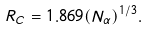<formula> <loc_0><loc_0><loc_500><loc_500>R _ { C } = 1 . 8 6 9 ( N _ { \alpha } ) ^ { 1 / 3 } .</formula> 